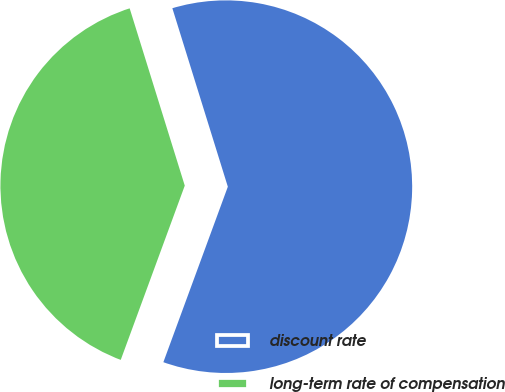Convert chart. <chart><loc_0><loc_0><loc_500><loc_500><pie_chart><fcel>discount rate<fcel>long-term rate of compensation<nl><fcel>60.4%<fcel>39.6%<nl></chart> 